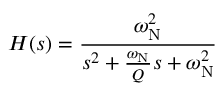Convert formula to latex. <formula><loc_0><loc_0><loc_500><loc_500>H ( s ) = { \frac { \omega _ { N } ^ { 2 } } { s ^ { 2 } + { \frac { \omega _ { N } } { Q } } s + \omega _ { N } ^ { 2 } } }</formula> 